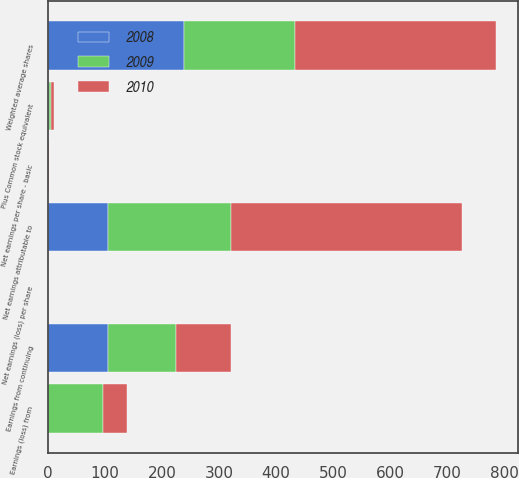Convert chart. <chart><loc_0><loc_0><loc_500><loc_500><stacked_bar_chart><ecel><fcel>Earnings from continuing<fcel>Earnings (loss) from<fcel>Net earnings attributable to<fcel>Weighted average shares<fcel>Plus Common stock equivalent<fcel>Net earnings per share - basic<fcel>Net earnings (loss) per share<nl><fcel>2010<fcel>95.9<fcel>43.1<fcel>404.5<fcel>352<fcel>6.9<fcel>1.3<fcel>0.12<nl><fcel>2008<fcel>106.4<fcel>0.5<fcel>105.9<fcel>239.4<fcel>3<fcel>0.45<fcel>0<nl><fcel>2009<fcel>118.9<fcel>95.9<fcel>214.8<fcel>193.5<fcel>1.9<fcel>0.62<fcel>0.5<nl></chart> 